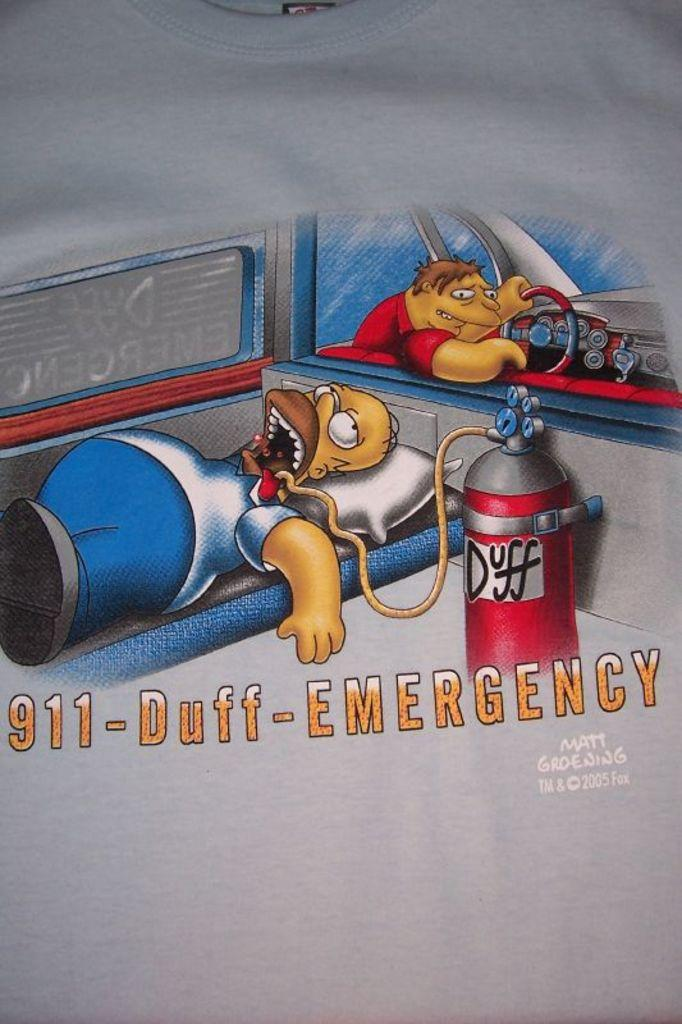<image>
Offer a succinct explanation of the picture presented. Homer Simpson lays in an ambulance with a rubber hose in his mouth that is connected to a canister saying Duff. 